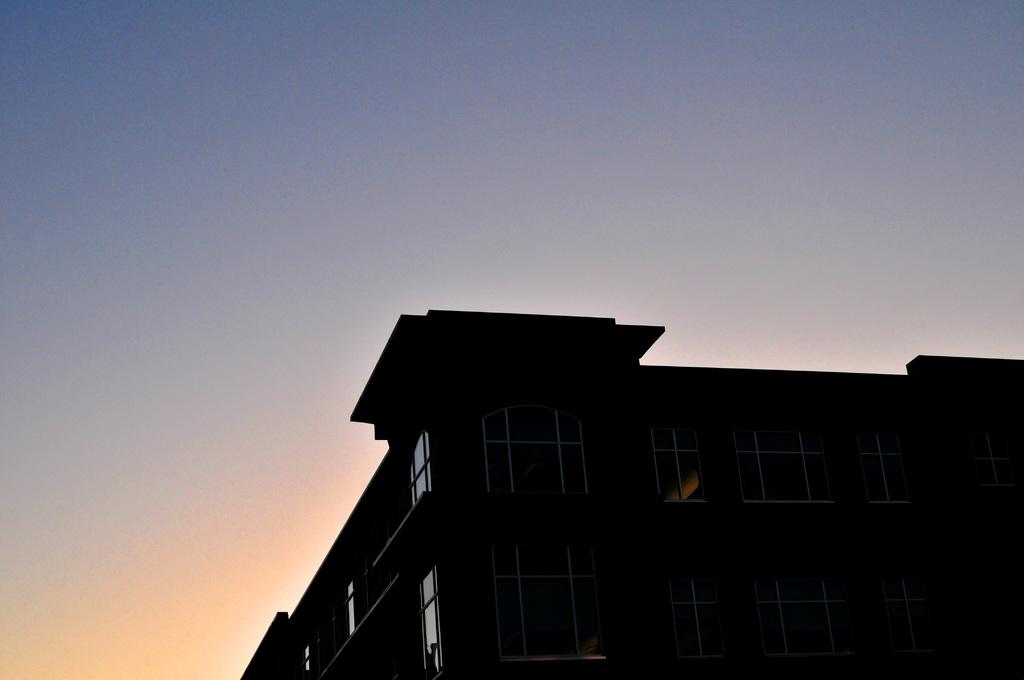What structure is located on the right side of the image? There is a building on the right side of the image. What feature can be observed on the building? The building has glass windows. What color is the sky in the background of the image? The sky is blue in the background of the image. Can you tell me how many minutes it takes for the mother to walk across the image? There is no mother or indication of time in the image, so it is not possible to answer that question. 